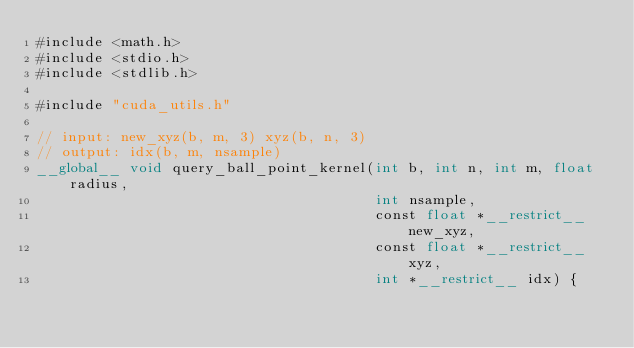<code> <loc_0><loc_0><loc_500><loc_500><_Cuda_>#include <math.h>
#include <stdio.h>
#include <stdlib.h>

#include "cuda_utils.h"

// input: new_xyz(b, m, 3) xyz(b, n, 3)
// output: idx(b, m, nsample)
__global__ void query_ball_point_kernel(int b, int n, int m, float radius,
                                        int nsample,
                                        const float *__restrict__ new_xyz,
                                        const float *__restrict__ xyz,
                                        int *__restrict__ idx) {</code> 